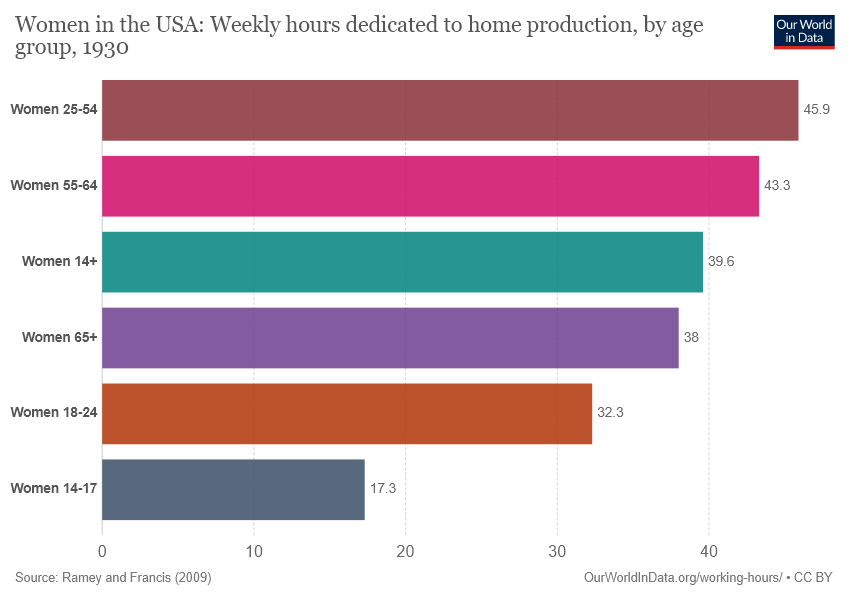Highlight a few significant elements in this photo. The smallest bar has a value of 17.3. The sum of the two smallest bars is greater than the largest bar. 